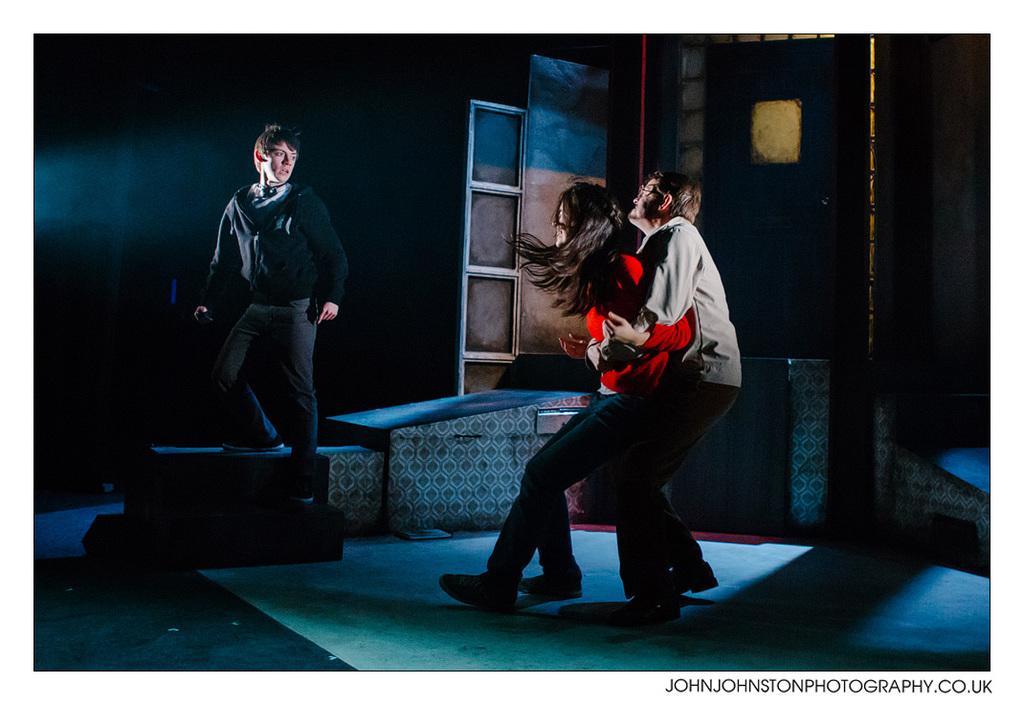Can you describe this image briefly? In this picture we can see a woman and two men, in the bottom right hand corner we can see some text and we can see dark background. 